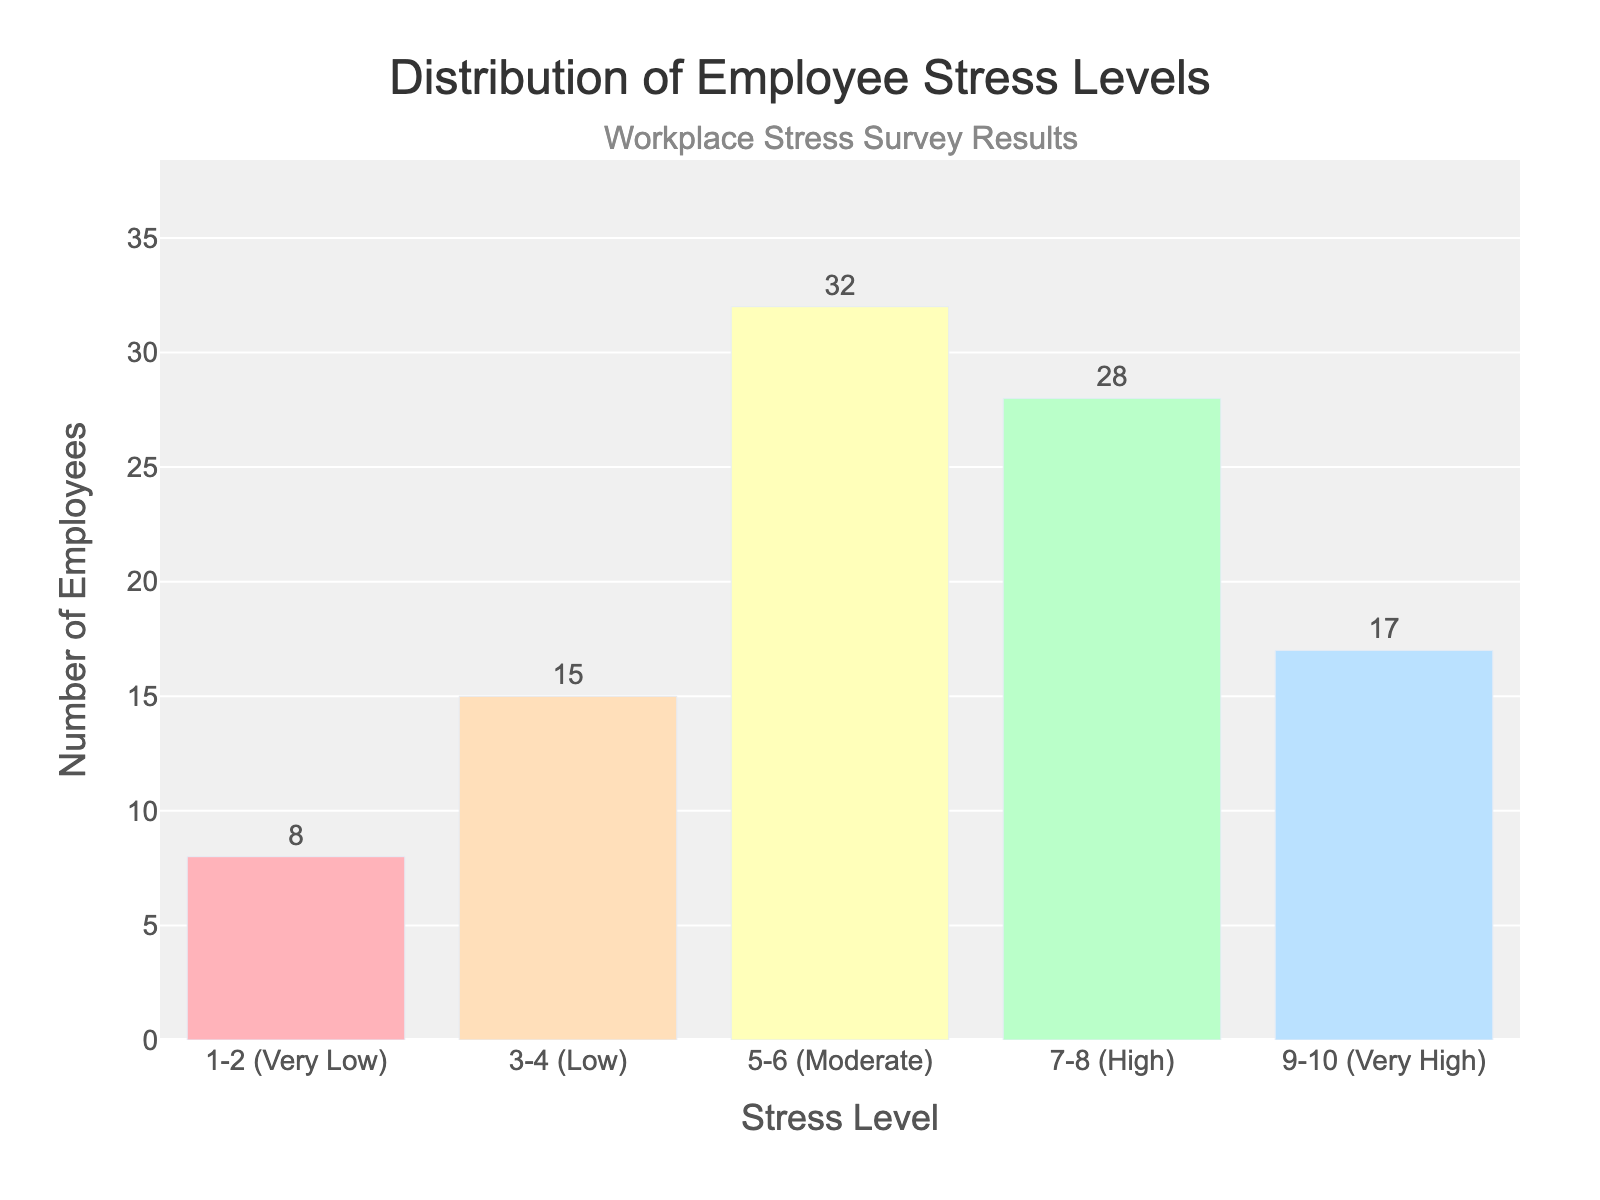What is the title of the plot? The title of the plot is the text at the top, which states the topic of the data visualized.
Answer: Distribution of Employee Stress Levels What is the range of stress levels displayed on the x-axis? The x-axis labels show the stress levels, which range from '1-2 (Very Low)' to '9-10 (Very High)'.
Answer: 1-2 (Very Low) to 9-10 (Very High) Which stress level has the highest number of employees? To determine this, look for the highest bar in the histogram. The '5-6 (Moderate)' stress level has the highest frequency with 32 employees.
Answer: 5-6 (Moderate) How many employees fall under the 'Very High' stress level category? The height of the bar labeled '9-10 (Very High)' gives this information, and the bar reaches up to 17 employees.
Answer: 17 What is the total number of employees surveyed? Sum the frequencies of all bars. 8 + 15 + 32 + 28 + 17 = 100.
Answer: 100 Compare the number of employees in the 'Low' stress level to those in the 'High' stress level. Which is greater and by how much? The 'Low' (3-4) stress level has 15 employees, and the 'High' (7-8) stress level has 28 employees. 28 - 15 = 13, so there are 13 more employees in the 'High' stress level.
Answer: 'High' by 13 What percentage of the employees experience 'Moderate' stress levels? Divide the frequency of 'Moderate' stress level by the total number of employees and multiply by 100. (32 / 100) * 100 = 32%.
Answer: 32% How does the number of employees in the 'Very Low' stress level compare to the 'Very High' stress level? The 'Very Low' (1-2) stress level has 8 employees, while the ‘Very High’ (9-10) stress level has 17 employees. 17 - 8 = 9, so the 'Very High' stress level has 9 more employees than the 'Very Low' level.
Answer: 'Very High' by 9 Which stress level category has the second highest number of employees? The second highest bar in the histogram represents the 'High' (7-8) stress level, with 28 employees.
Answer: 7-8 (High) What is the difference in the number of employees between the 'Moderate' and 'Low' stress levels? Subtract the frequency of 'Low' stress level from 'Moderate' stress level. 32 - 15 = 17.
Answer: 17 